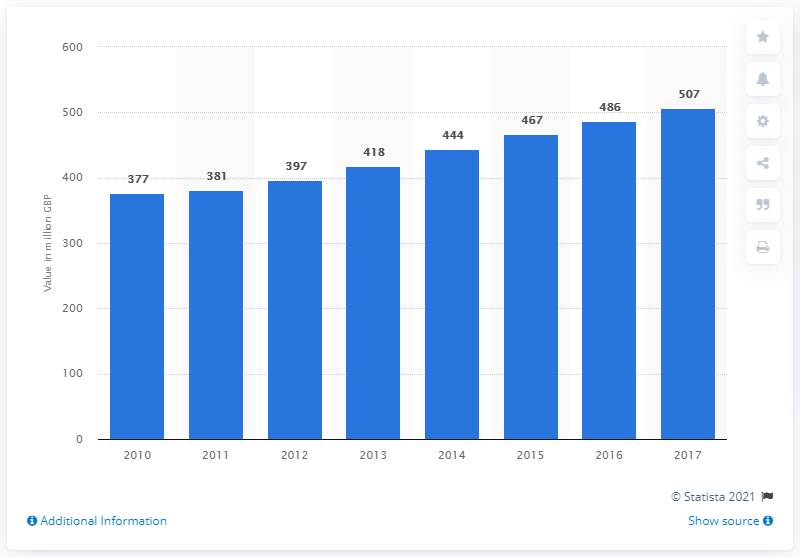Highlight a few significant elements in this photo. The UK's network equipment segment was first analyzed by IT product and service type in 2010. In 2017, the estimated market size of the network equipment segment in the cyber security industry was 507. 